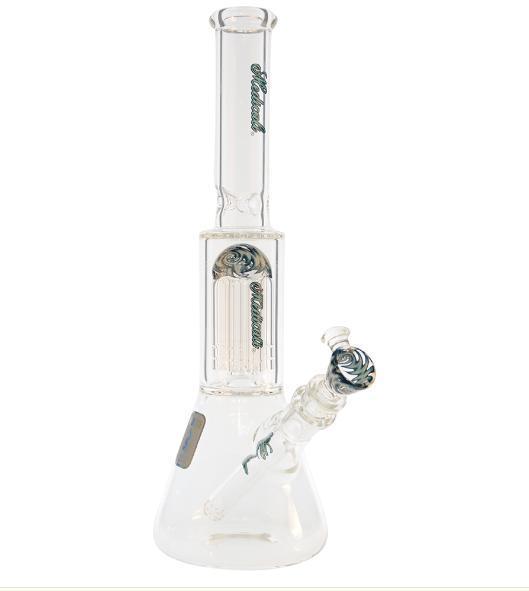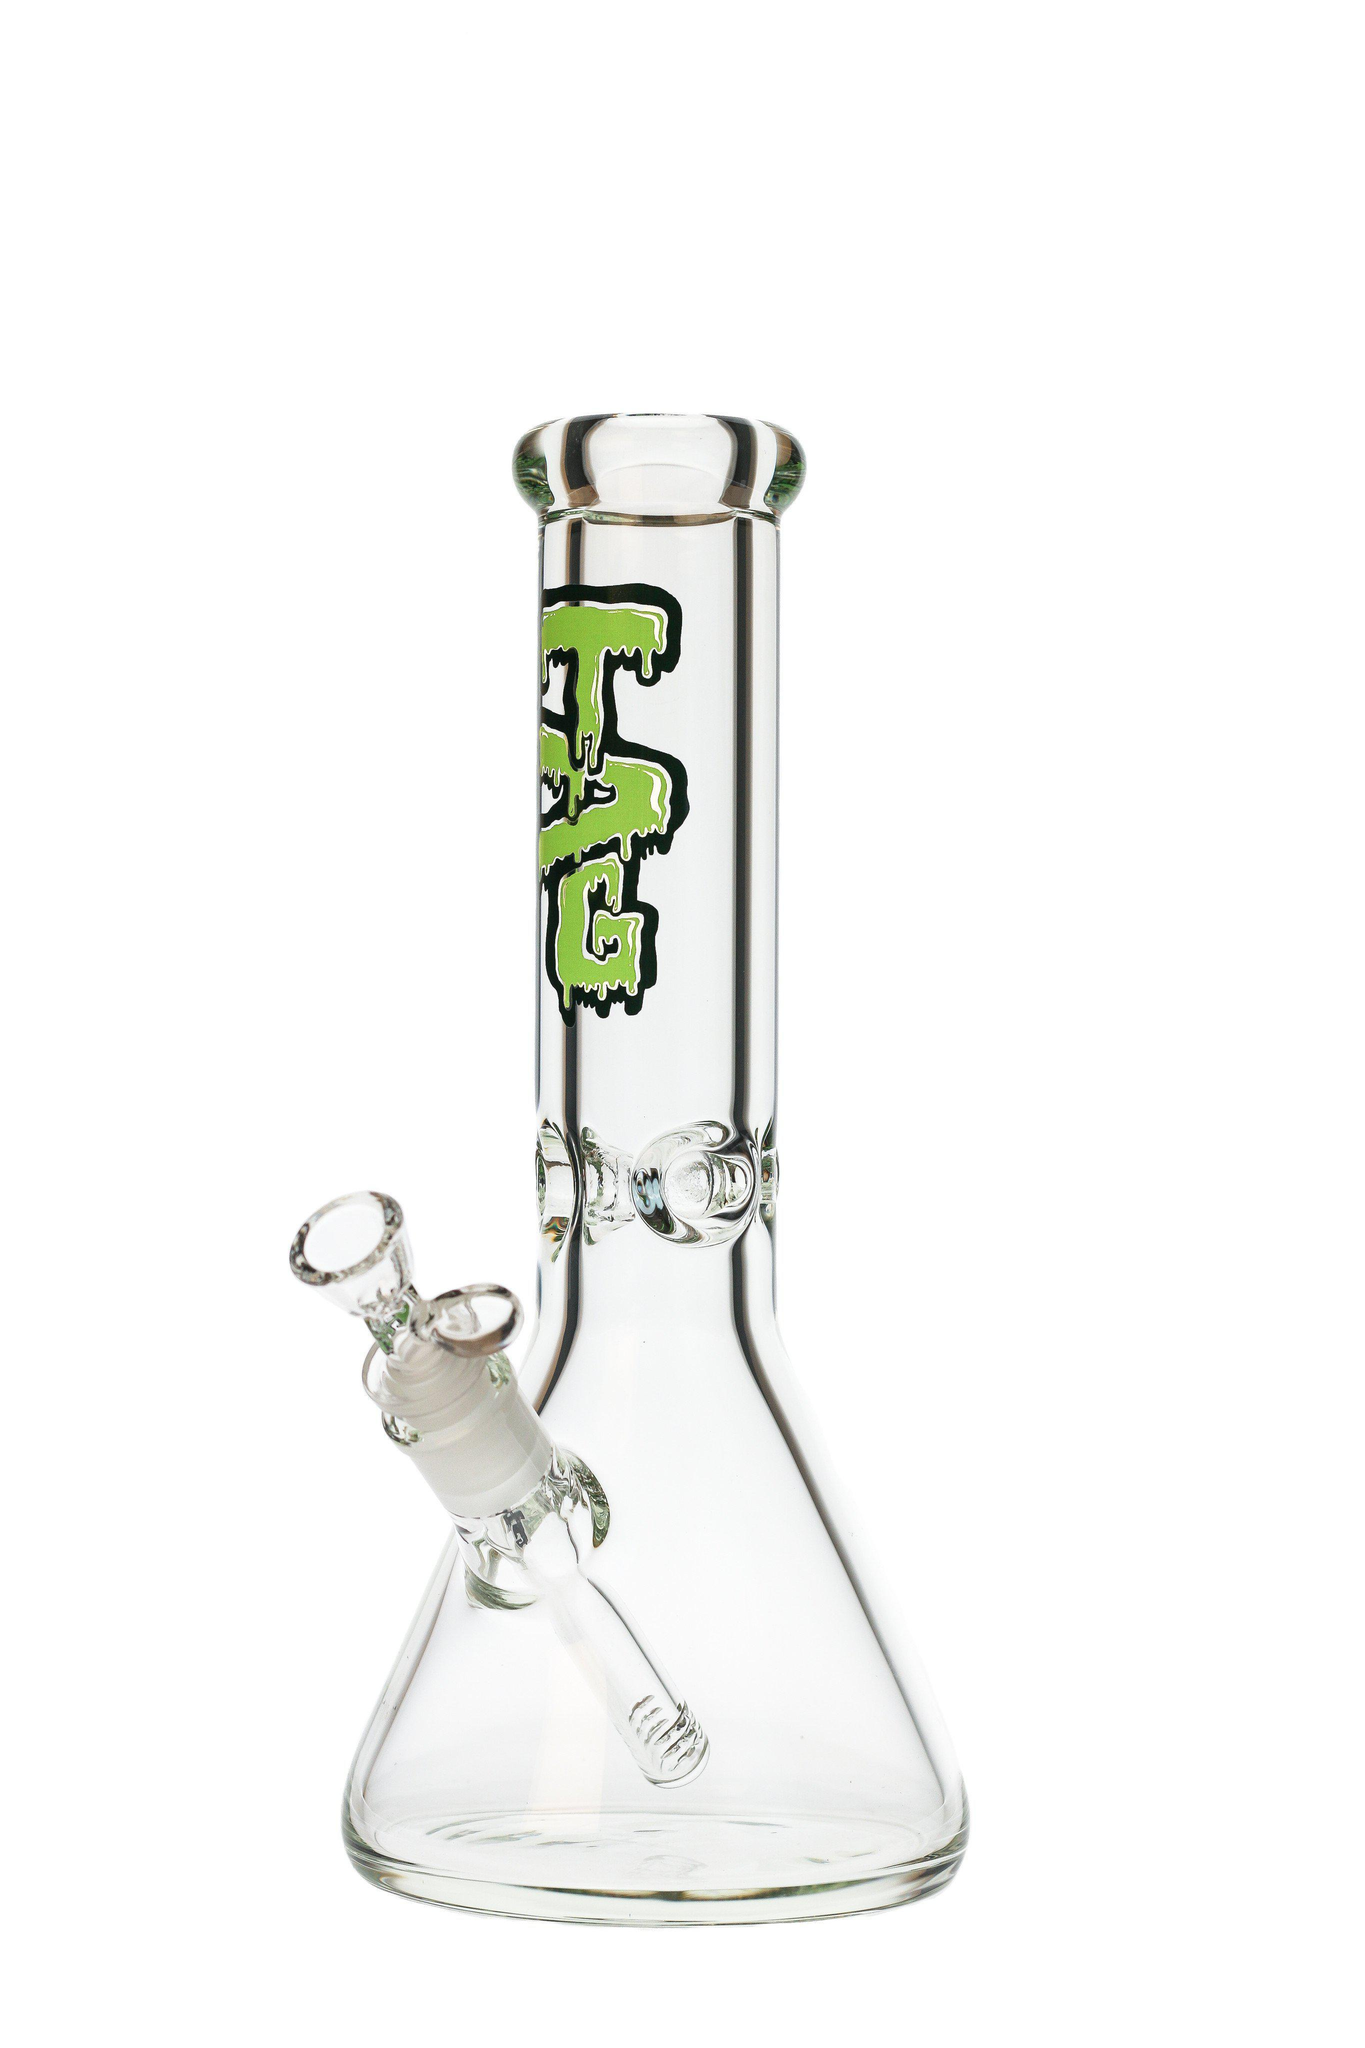The first image is the image on the left, the second image is the image on the right. Analyze the images presented: Is the assertion "The bowls of both bongs face the same direction." valid? Answer yes or no. No. The first image is the image on the left, the second image is the image on the right. For the images shown, is this caption "There are a total of two beaker bongs with the mouth pieces facing forward and left." true? Answer yes or no. No. 